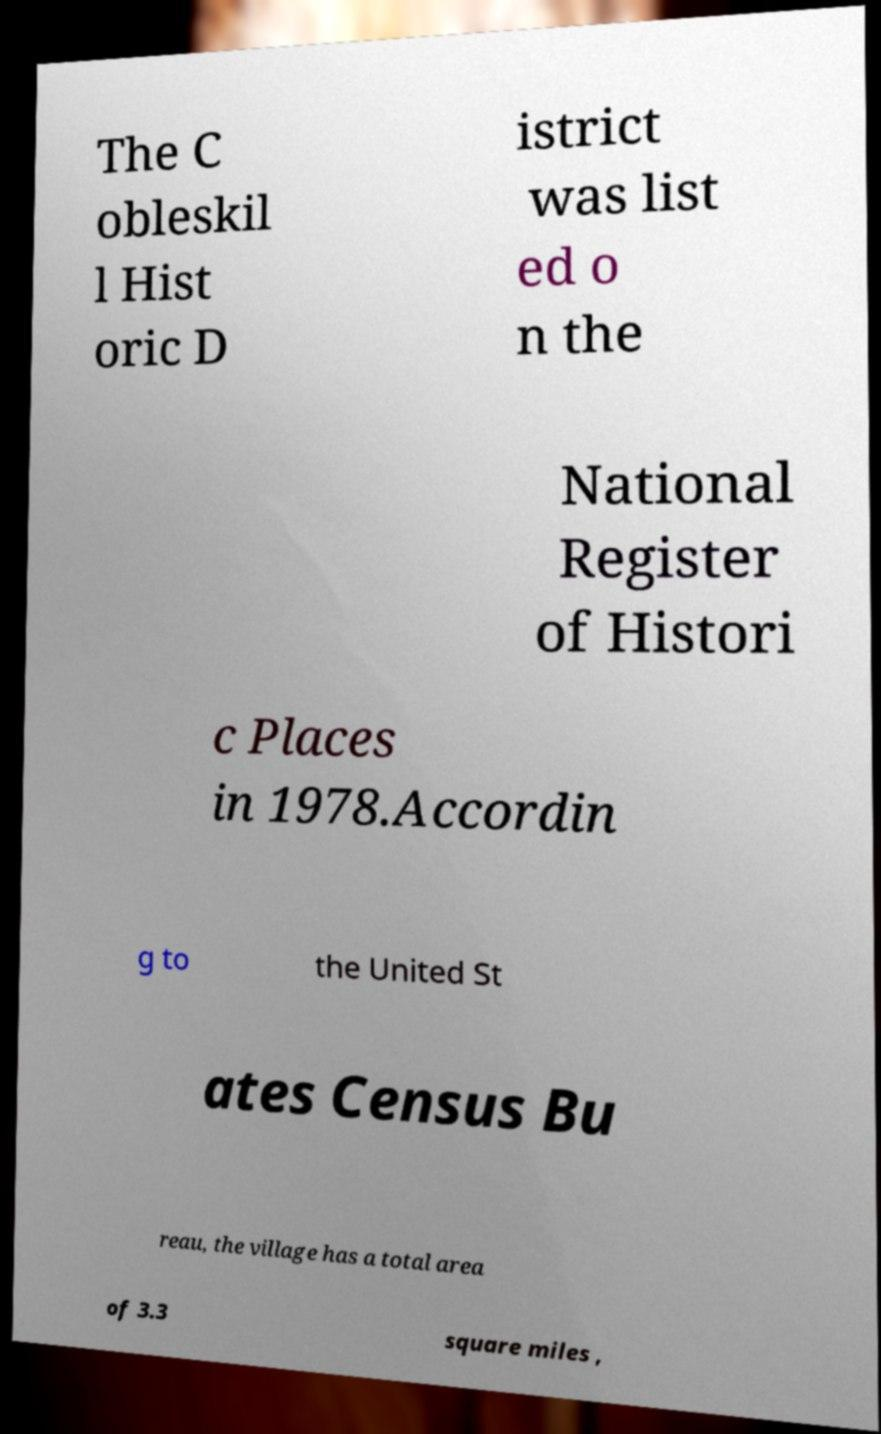There's text embedded in this image that I need extracted. Can you transcribe it verbatim? The C obleskil l Hist oric D istrict was list ed o n the National Register of Histori c Places in 1978.Accordin g to the United St ates Census Bu reau, the village has a total area of 3.3 square miles , 